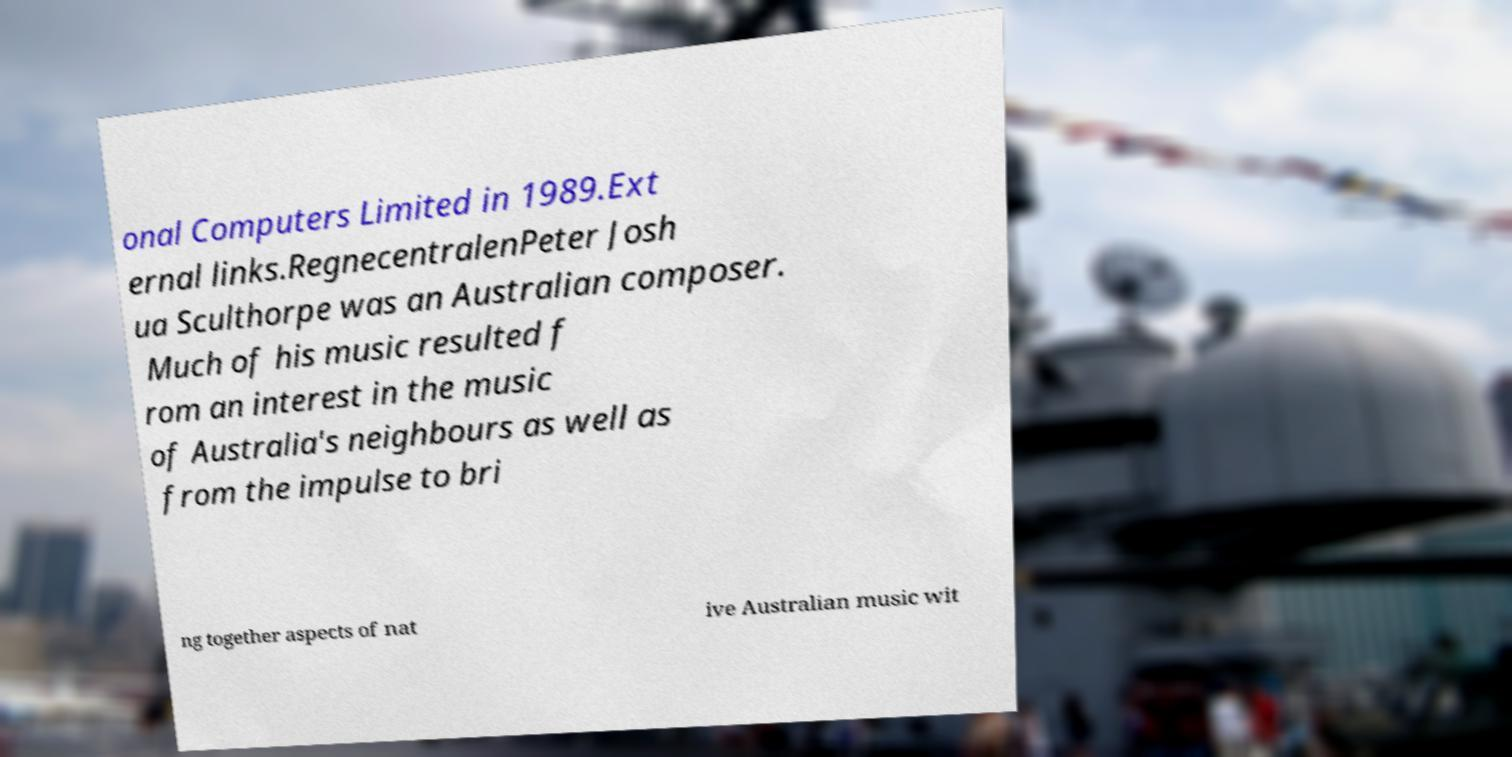Can you read and provide the text displayed in the image?This photo seems to have some interesting text. Can you extract and type it out for me? onal Computers Limited in 1989.Ext ernal links.RegnecentralenPeter Josh ua Sculthorpe was an Australian composer. Much of his music resulted f rom an interest in the music of Australia's neighbours as well as from the impulse to bri ng together aspects of nat ive Australian music wit 